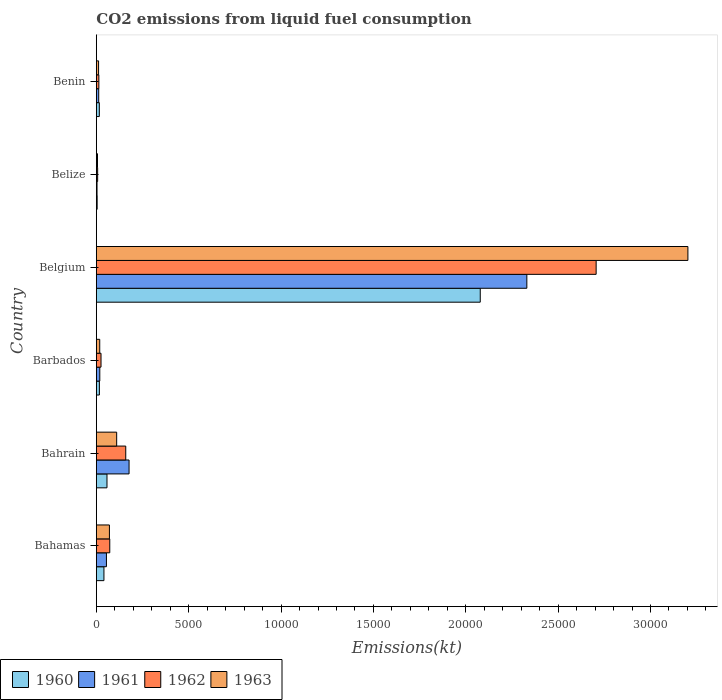How many groups of bars are there?
Offer a very short reply. 6. What is the label of the 5th group of bars from the top?
Offer a terse response. Bahrain. In how many cases, is the number of bars for a given country not equal to the number of legend labels?
Your answer should be compact. 0. What is the amount of CO2 emitted in 1960 in Bahamas?
Offer a very short reply. 410.7. Across all countries, what is the maximum amount of CO2 emitted in 1963?
Your response must be concise. 3.20e+04. Across all countries, what is the minimum amount of CO2 emitted in 1962?
Give a very brief answer. 69.67. In which country was the amount of CO2 emitted in 1962 maximum?
Your answer should be very brief. Belgium. In which country was the amount of CO2 emitted in 1960 minimum?
Your answer should be very brief. Belize. What is the total amount of CO2 emitted in 1963 in the graph?
Provide a succinct answer. 3.42e+04. What is the difference between the amount of CO2 emitted in 1961 in Belgium and that in Benin?
Provide a short and direct response. 2.32e+04. What is the difference between the amount of CO2 emitted in 1963 in Barbados and the amount of CO2 emitted in 1961 in Belgium?
Offer a very short reply. -2.31e+04. What is the average amount of CO2 emitted in 1963 per country?
Your answer should be very brief. 5700.35. What is the difference between the amount of CO2 emitted in 1960 and amount of CO2 emitted in 1962 in Barbados?
Provide a short and direct response. -88.01. In how many countries, is the amount of CO2 emitted in 1962 greater than 4000 kt?
Make the answer very short. 1. What is the ratio of the amount of CO2 emitted in 1963 in Bahamas to that in Benin?
Provide a short and direct response. 5.85. Is the amount of CO2 emitted in 1960 in Barbados less than that in Benin?
Provide a short and direct response. No. Is the difference between the amount of CO2 emitted in 1960 in Bahamas and Benin greater than the difference between the amount of CO2 emitted in 1962 in Bahamas and Benin?
Ensure brevity in your answer.  No. What is the difference between the highest and the second highest amount of CO2 emitted in 1962?
Offer a terse response. 2.55e+04. What is the difference between the highest and the lowest amount of CO2 emitted in 1960?
Your response must be concise. 2.07e+04. What does the 3rd bar from the top in Belgium represents?
Give a very brief answer. 1961. Are all the bars in the graph horizontal?
Make the answer very short. Yes. What is the difference between two consecutive major ticks on the X-axis?
Your answer should be very brief. 5000. Are the values on the major ticks of X-axis written in scientific E-notation?
Ensure brevity in your answer.  No. How many legend labels are there?
Your response must be concise. 4. What is the title of the graph?
Your answer should be very brief. CO2 emissions from liquid fuel consumption. Does "1988" appear as one of the legend labels in the graph?
Give a very brief answer. No. What is the label or title of the X-axis?
Provide a short and direct response. Emissions(kt). What is the Emissions(kt) of 1960 in Bahamas?
Your response must be concise. 410.7. What is the Emissions(kt) in 1961 in Bahamas?
Your answer should be compact. 546.38. What is the Emissions(kt) of 1962 in Bahamas?
Keep it short and to the point. 726.07. What is the Emissions(kt) of 1963 in Bahamas?
Provide a succinct answer. 707.73. What is the Emissions(kt) of 1960 in Bahrain?
Keep it short and to the point. 575.72. What is the Emissions(kt) of 1961 in Bahrain?
Offer a very short reply. 1771.16. What is the Emissions(kt) in 1962 in Bahrain?
Offer a very short reply. 1591.48. What is the Emissions(kt) in 1963 in Bahrain?
Provide a succinct answer. 1100.1. What is the Emissions(kt) in 1960 in Barbados?
Ensure brevity in your answer.  165.01. What is the Emissions(kt) of 1961 in Barbados?
Your response must be concise. 187.02. What is the Emissions(kt) of 1962 in Barbados?
Give a very brief answer. 253.02. What is the Emissions(kt) of 1963 in Barbados?
Offer a terse response. 183.35. What is the Emissions(kt) of 1960 in Belgium?
Ensure brevity in your answer.  2.08e+04. What is the Emissions(kt) in 1961 in Belgium?
Your response must be concise. 2.33e+04. What is the Emissions(kt) of 1962 in Belgium?
Your response must be concise. 2.71e+04. What is the Emissions(kt) of 1963 in Belgium?
Offer a terse response. 3.20e+04. What is the Emissions(kt) in 1960 in Belize?
Provide a short and direct response. 44. What is the Emissions(kt) of 1961 in Belize?
Your answer should be very brief. 36.67. What is the Emissions(kt) of 1962 in Belize?
Your answer should be very brief. 69.67. What is the Emissions(kt) in 1963 in Belize?
Offer a very short reply. 62.34. What is the Emissions(kt) of 1960 in Benin?
Your response must be concise. 161.35. What is the Emissions(kt) of 1961 in Benin?
Your answer should be very brief. 128.34. What is the Emissions(kt) in 1962 in Benin?
Your answer should be very brief. 135.68. What is the Emissions(kt) in 1963 in Benin?
Offer a very short reply. 121.01. Across all countries, what is the maximum Emissions(kt) of 1960?
Ensure brevity in your answer.  2.08e+04. Across all countries, what is the maximum Emissions(kt) of 1961?
Your answer should be compact. 2.33e+04. Across all countries, what is the maximum Emissions(kt) of 1962?
Your response must be concise. 2.71e+04. Across all countries, what is the maximum Emissions(kt) in 1963?
Provide a succinct answer. 3.20e+04. Across all countries, what is the minimum Emissions(kt) in 1960?
Your answer should be very brief. 44. Across all countries, what is the minimum Emissions(kt) in 1961?
Your answer should be very brief. 36.67. Across all countries, what is the minimum Emissions(kt) in 1962?
Your answer should be very brief. 69.67. Across all countries, what is the minimum Emissions(kt) of 1963?
Your answer should be very brief. 62.34. What is the total Emissions(kt) of 1960 in the graph?
Your answer should be very brief. 2.21e+04. What is the total Emissions(kt) in 1961 in the graph?
Ensure brevity in your answer.  2.60e+04. What is the total Emissions(kt) in 1962 in the graph?
Ensure brevity in your answer.  2.98e+04. What is the total Emissions(kt) of 1963 in the graph?
Offer a very short reply. 3.42e+04. What is the difference between the Emissions(kt) in 1960 in Bahamas and that in Bahrain?
Keep it short and to the point. -165.01. What is the difference between the Emissions(kt) of 1961 in Bahamas and that in Bahrain?
Offer a terse response. -1224.78. What is the difference between the Emissions(kt) in 1962 in Bahamas and that in Bahrain?
Provide a short and direct response. -865.41. What is the difference between the Emissions(kt) of 1963 in Bahamas and that in Bahrain?
Keep it short and to the point. -392.37. What is the difference between the Emissions(kt) in 1960 in Bahamas and that in Barbados?
Provide a short and direct response. 245.69. What is the difference between the Emissions(kt) in 1961 in Bahamas and that in Barbados?
Your answer should be compact. 359.37. What is the difference between the Emissions(kt) of 1962 in Bahamas and that in Barbados?
Ensure brevity in your answer.  473.04. What is the difference between the Emissions(kt) of 1963 in Bahamas and that in Barbados?
Your answer should be very brief. 524.38. What is the difference between the Emissions(kt) of 1960 in Bahamas and that in Belgium?
Provide a short and direct response. -2.04e+04. What is the difference between the Emissions(kt) in 1961 in Bahamas and that in Belgium?
Provide a short and direct response. -2.28e+04. What is the difference between the Emissions(kt) in 1962 in Bahamas and that in Belgium?
Your answer should be very brief. -2.63e+04. What is the difference between the Emissions(kt) of 1963 in Bahamas and that in Belgium?
Make the answer very short. -3.13e+04. What is the difference between the Emissions(kt) of 1960 in Bahamas and that in Belize?
Your response must be concise. 366.7. What is the difference between the Emissions(kt) in 1961 in Bahamas and that in Belize?
Make the answer very short. 509.71. What is the difference between the Emissions(kt) in 1962 in Bahamas and that in Belize?
Ensure brevity in your answer.  656.39. What is the difference between the Emissions(kt) of 1963 in Bahamas and that in Belize?
Offer a very short reply. 645.39. What is the difference between the Emissions(kt) in 1960 in Bahamas and that in Benin?
Your answer should be very brief. 249.36. What is the difference between the Emissions(kt) in 1961 in Bahamas and that in Benin?
Offer a very short reply. 418.04. What is the difference between the Emissions(kt) of 1962 in Bahamas and that in Benin?
Provide a short and direct response. 590.39. What is the difference between the Emissions(kt) of 1963 in Bahamas and that in Benin?
Provide a succinct answer. 586.72. What is the difference between the Emissions(kt) of 1960 in Bahrain and that in Barbados?
Make the answer very short. 410.7. What is the difference between the Emissions(kt) of 1961 in Bahrain and that in Barbados?
Keep it short and to the point. 1584.14. What is the difference between the Emissions(kt) in 1962 in Bahrain and that in Barbados?
Your answer should be very brief. 1338.45. What is the difference between the Emissions(kt) in 1963 in Bahrain and that in Barbados?
Your answer should be compact. 916.75. What is the difference between the Emissions(kt) in 1960 in Bahrain and that in Belgium?
Offer a very short reply. -2.02e+04. What is the difference between the Emissions(kt) in 1961 in Bahrain and that in Belgium?
Your response must be concise. -2.15e+04. What is the difference between the Emissions(kt) in 1962 in Bahrain and that in Belgium?
Provide a succinct answer. -2.55e+04. What is the difference between the Emissions(kt) in 1963 in Bahrain and that in Belgium?
Your answer should be very brief. -3.09e+04. What is the difference between the Emissions(kt) in 1960 in Bahrain and that in Belize?
Your response must be concise. 531.72. What is the difference between the Emissions(kt) of 1961 in Bahrain and that in Belize?
Give a very brief answer. 1734.49. What is the difference between the Emissions(kt) in 1962 in Bahrain and that in Belize?
Make the answer very short. 1521.81. What is the difference between the Emissions(kt) of 1963 in Bahrain and that in Belize?
Make the answer very short. 1037.76. What is the difference between the Emissions(kt) of 1960 in Bahrain and that in Benin?
Your answer should be compact. 414.37. What is the difference between the Emissions(kt) of 1961 in Bahrain and that in Benin?
Ensure brevity in your answer.  1642.82. What is the difference between the Emissions(kt) of 1962 in Bahrain and that in Benin?
Provide a short and direct response. 1455.8. What is the difference between the Emissions(kt) in 1963 in Bahrain and that in Benin?
Provide a succinct answer. 979.09. What is the difference between the Emissions(kt) of 1960 in Barbados and that in Belgium?
Your answer should be compact. -2.06e+04. What is the difference between the Emissions(kt) of 1961 in Barbados and that in Belgium?
Offer a very short reply. -2.31e+04. What is the difference between the Emissions(kt) of 1962 in Barbados and that in Belgium?
Provide a short and direct response. -2.68e+04. What is the difference between the Emissions(kt) of 1963 in Barbados and that in Belgium?
Give a very brief answer. -3.18e+04. What is the difference between the Emissions(kt) of 1960 in Barbados and that in Belize?
Offer a very short reply. 121.01. What is the difference between the Emissions(kt) of 1961 in Barbados and that in Belize?
Provide a short and direct response. 150.35. What is the difference between the Emissions(kt) in 1962 in Barbados and that in Belize?
Provide a succinct answer. 183.35. What is the difference between the Emissions(kt) in 1963 in Barbados and that in Belize?
Your answer should be very brief. 121.01. What is the difference between the Emissions(kt) in 1960 in Barbados and that in Benin?
Offer a very short reply. 3.67. What is the difference between the Emissions(kt) in 1961 in Barbados and that in Benin?
Provide a short and direct response. 58.67. What is the difference between the Emissions(kt) of 1962 in Barbados and that in Benin?
Offer a terse response. 117.34. What is the difference between the Emissions(kt) in 1963 in Barbados and that in Benin?
Offer a very short reply. 62.34. What is the difference between the Emissions(kt) of 1960 in Belgium and that in Belize?
Provide a succinct answer. 2.07e+04. What is the difference between the Emissions(kt) in 1961 in Belgium and that in Belize?
Keep it short and to the point. 2.33e+04. What is the difference between the Emissions(kt) in 1962 in Belgium and that in Belize?
Provide a succinct answer. 2.70e+04. What is the difference between the Emissions(kt) of 1963 in Belgium and that in Belize?
Offer a very short reply. 3.20e+04. What is the difference between the Emissions(kt) in 1960 in Belgium and that in Benin?
Your answer should be compact. 2.06e+04. What is the difference between the Emissions(kt) of 1961 in Belgium and that in Benin?
Make the answer very short. 2.32e+04. What is the difference between the Emissions(kt) in 1962 in Belgium and that in Benin?
Your answer should be very brief. 2.69e+04. What is the difference between the Emissions(kt) in 1963 in Belgium and that in Benin?
Provide a short and direct response. 3.19e+04. What is the difference between the Emissions(kt) of 1960 in Belize and that in Benin?
Provide a succinct answer. -117.34. What is the difference between the Emissions(kt) in 1961 in Belize and that in Benin?
Provide a succinct answer. -91.67. What is the difference between the Emissions(kt) of 1962 in Belize and that in Benin?
Provide a short and direct response. -66.01. What is the difference between the Emissions(kt) of 1963 in Belize and that in Benin?
Keep it short and to the point. -58.67. What is the difference between the Emissions(kt) in 1960 in Bahamas and the Emissions(kt) in 1961 in Bahrain?
Offer a terse response. -1360.46. What is the difference between the Emissions(kt) in 1960 in Bahamas and the Emissions(kt) in 1962 in Bahrain?
Your answer should be very brief. -1180.77. What is the difference between the Emissions(kt) in 1960 in Bahamas and the Emissions(kt) in 1963 in Bahrain?
Provide a short and direct response. -689.4. What is the difference between the Emissions(kt) of 1961 in Bahamas and the Emissions(kt) of 1962 in Bahrain?
Keep it short and to the point. -1045.1. What is the difference between the Emissions(kt) of 1961 in Bahamas and the Emissions(kt) of 1963 in Bahrain?
Ensure brevity in your answer.  -553.72. What is the difference between the Emissions(kt) of 1962 in Bahamas and the Emissions(kt) of 1963 in Bahrain?
Offer a terse response. -374.03. What is the difference between the Emissions(kt) of 1960 in Bahamas and the Emissions(kt) of 1961 in Barbados?
Your response must be concise. 223.69. What is the difference between the Emissions(kt) of 1960 in Bahamas and the Emissions(kt) of 1962 in Barbados?
Offer a terse response. 157.68. What is the difference between the Emissions(kt) of 1960 in Bahamas and the Emissions(kt) of 1963 in Barbados?
Your answer should be compact. 227.35. What is the difference between the Emissions(kt) in 1961 in Bahamas and the Emissions(kt) in 1962 in Barbados?
Make the answer very short. 293.36. What is the difference between the Emissions(kt) in 1961 in Bahamas and the Emissions(kt) in 1963 in Barbados?
Provide a succinct answer. 363.03. What is the difference between the Emissions(kt) of 1962 in Bahamas and the Emissions(kt) of 1963 in Barbados?
Your response must be concise. 542.72. What is the difference between the Emissions(kt) of 1960 in Bahamas and the Emissions(kt) of 1961 in Belgium?
Provide a succinct answer. -2.29e+04. What is the difference between the Emissions(kt) in 1960 in Bahamas and the Emissions(kt) in 1962 in Belgium?
Your answer should be compact. -2.66e+04. What is the difference between the Emissions(kt) of 1960 in Bahamas and the Emissions(kt) of 1963 in Belgium?
Your response must be concise. -3.16e+04. What is the difference between the Emissions(kt) of 1961 in Bahamas and the Emissions(kt) of 1962 in Belgium?
Your answer should be very brief. -2.65e+04. What is the difference between the Emissions(kt) of 1961 in Bahamas and the Emissions(kt) of 1963 in Belgium?
Ensure brevity in your answer.  -3.15e+04. What is the difference between the Emissions(kt) in 1962 in Bahamas and the Emissions(kt) in 1963 in Belgium?
Provide a short and direct response. -3.13e+04. What is the difference between the Emissions(kt) of 1960 in Bahamas and the Emissions(kt) of 1961 in Belize?
Offer a terse response. 374.03. What is the difference between the Emissions(kt) in 1960 in Bahamas and the Emissions(kt) in 1962 in Belize?
Keep it short and to the point. 341.03. What is the difference between the Emissions(kt) in 1960 in Bahamas and the Emissions(kt) in 1963 in Belize?
Your answer should be compact. 348.37. What is the difference between the Emissions(kt) in 1961 in Bahamas and the Emissions(kt) in 1962 in Belize?
Give a very brief answer. 476.71. What is the difference between the Emissions(kt) of 1961 in Bahamas and the Emissions(kt) of 1963 in Belize?
Your response must be concise. 484.04. What is the difference between the Emissions(kt) in 1962 in Bahamas and the Emissions(kt) in 1963 in Belize?
Provide a succinct answer. 663.73. What is the difference between the Emissions(kt) in 1960 in Bahamas and the Emissions(kt) in 1961 in Benin?
Provide a succinct answer. 282.36. What is the difference between the Emissions(kt) of 1960 in Bahamas and the Emissions(kt) of 1962 in Benin?
Your answer should be compact. 275.02. What is the difference between the Emissions(kt) of 1960 in Bahamas and the Emissions(kt) of 1963 in Benin?
Offer a terse response. 289.69. What is the difference between the Emissions(kt) in 1961 in Bahamas and the Emissions(kt) in 1962 in Benin?
Provide a short and direct response. 410.7. What is the difference between the Emissions(kt) in 1961 in Bahamas and the Emissions(kt) in 1963 in Benin?
Your answer should be compact. 425.37. What is the difference between the Emissions(kt) of 1962 in Bahamas and the Emissions(kt) of 1963 in Benin?
Offer a terse response. 605.05. What is the difference between the Emissions(kt) in 1960 in Bahrain and the Emissions(kt) in 1961 in Barbados?
Your response must be concise. 388.7. What is the difference between the Emissions(kt) of 1960 in Bahrain and the Emissions(kt) of 1962 in Barbados?
Offer a very short reply. 322.7. What is the difference between the Emissions(kt) of 1960 in Bahrain and the Emissions(kt) of 1963 in Barbados?
Your answer should be compact. 392.37. What is the difference between the Emissions(kt) in 1961 in Bahrain and the Emissions(kt) in 1962 in Barbados?
Provide a short and direct response. 1518.14. What is the difference between the Emissions(kt) in 1961 in Bahrain and the Emissions(kt) in 1963 in Barbados?
Offer a terse response. 1587.81. What is the difference between the Emissions(kt) of 1962 in Bahrain and the Emissions(kt) of 1963 in Barbados?
Keep it short and to the point. 1408.13. What is the difference between the Emissions(kt) of 1960 in Bahrain and the Emissions(kt) of 1961 in Belgium?
Your answer should be very brief. -2.27e+04. What is the difference between the Emissions(kt) in 1960 in Bahrain and the Emissions(kt) in 1962 in Belgium?
Give a very brief answer. -2.65e+04. What is the difference between the Emissions(kt) of 1960 in Bahrain and the Emissions(kt) of 1963 in Belgium?
Provide a short and direct response. -3.15e+04. What is the difference between the Emissions(kt) in 1961 in Bahrain and the Emissions(kt) in 1962 in Belgium?
Ensure brevity in your answer.  -2.53e+04. What is the difference between the Emissions(kt) in 1961 in Bahrain and the Emissions(kt) in 1963 in Belgium?
Provide a succinct answer. -3.03e+04. What is the difference between the Emissions(kt) in 1962 in Bahrain and the Emissions(kt) in 1963 in Belgium?
Keep it short and to the point. -3.04e+04. What is the difference between the Emissions(kt) of 1960 in Bahrain and the Emissions(kt) of 1961 in Belize?
Make the answer very short. 539.05. What is the difference between the Emissions(kt) of 1960 in Bahrain and the Emissions(kt) of 1962 in Belize?
Give a very brief answer. 506.05. What is the difference between the Emissions(kt) in 1960 in Bahrain and the Emissions(kt) in 1963 in Belize?
Give a very brief answer. 513.38. What is the difference between the Emissions(kt) of 1961 in Bahrain and the Emissions(kt) of 1962 in Belize?
Provide a short and direct response. 1701.49. What is the difference between the Emissions(kt) in 1961 in Bahrain and the Emissions(kt) in 1963 in Belize?
Provide a short and direct response. 1708.82. What is the difference between the Emissions(kt) of 1962 in Bahrain and the Emissions(kt) of 1963 in Belize?
Make the answer very short. 1529.14. What is the difference between the Emissions(kt) of 1960 in Bahrain and the Emissions(kt) of 1961 in Benin?
Offer a terse response. 447.37. What is the difference between the Emissions(kt) of 1960 in Bahrain and the Emissions(kt) of 1962 in Benin?
Ensure brevity in your answer.  440.04. What is the difference between the Emissions(kt) of 1960 in Bahrain and the Emissions(kt) of 1963 in Benin?
Your response must be concise. 454.71. What is the difference between the Emissions(kt) in 1961 in Bahrain and the Emissions(kt) in 1962 in Benin?
Give a very brief answer. 1635.48. What is the difference between the Emissions(kt) of 1961 in Bahrain and the Emissions(kt) of 1963 in Benin?
Your answer should be very brief. 1650.15. What is the difference between the Emissions(kt) in 1962 in Bahrain and the Emissions(kt) in 1963 in Benin?
Provide a succinct answer. 1470.47. What is the difference between the Emissions(kt) of 1960 in Barbados and the Emissions(kt) of 1961 in Belgium?
Your answer should be very brief. -2.31e+04. What is the difference between the Emissions(kt) of 1960 in Barbados and the Emissions(kt) of 1962 in Belgium?
Make the answer very short. -2.69e+04. What is the difference between the Emissions(kt) in 1960 in Barbados and the Emissions(kt) in 1963 in Belgium?
Your answer should be compact. -3.19e+04. What is the difference between the Emissions(kt) of 1961 in Barbados and the Emissions(kt) of 1962 in Belgium?
Your answer should be very brief. -2.69e+04. What is the difference between the Emissions(kt) of 1961 in Barbados and the Emissions(kt) of 1963 in Belgium?
Provide a succinct answer. -3.18e+04. What is the difference between the Emissions(kt) of 1962 in Barbados and the Emissions(kt) of 1963 in Belgium?
Offer a very short reply. -3.18e+04. What is the difference between the Emissions(kt) of 1960 in Barbados and the Emissions(kt) of 1961 in Belize?
Your answer should be very brief. 128.34. What is the difference between the Emissions(kt) in 1960 in Barbados and the Emissions(kt) in 1962 in Belize?
Provide a succinct answer. 95.34. What is the difference between the Emissions(kt) of 1960 in Barbados and the Emissions(kt) of 1963 in Belize?
Give a very brief answer. 102.68. What is the difference between the Emissions(kt) of 1961 in Barbados and the Emissions(kt) of 1962 in Belize?
Offer a very short reply. 117.34. What is the difference between the Emissions(kt) in 1961 in Barbados and the Emissions(kt) in 1963 in Belize?
Give a very brief answer. 124.68. What is the difference between the Emissions(kt) in 1962 in Barbados and the Emissions(kt) in 1963 in Belize?
Make the answer very short. 190.68. What is the difference between the Emissions(kt) of 1960 in Barbados and the Emissions(kt) of 1961 in Benin?
Your response must be concise. 36.67. What is the difference between the Emissions(kt) of 1960 in Barbados and the Emissions(kt) of 1962 in Benin?
Your response must be concise. 29.34. What is the difference between the Emissions(kt) in 1960 in Barbados and the Emissions(kt) in 1963 in Benin?
Ensure brevity in your answer.  44. What is the difference between the Emissions(kt) in 1961 in Barbados and the Emissions(kt) in 1962 in Benin?
Offer a very short reply. 51.34. What is the difference between the Emissions(kt) in 1961 in Barbados and the Emissions(kt) in 1963 in Benin?
Your answer should be compact. 66.01. What is the difference between the Emissions(kt) in 1962 in Barbados and the Emissions(kt) in 1963 in Benin?
Keep it short and to the point. 132.01. What is the difference between the Emissions(kt) of 1960 in Belgium and the Emissions(kt) of 1961 in Belize?
Make the answer very short. 2.07e+04. What is the difference between the Emissions(kt) in 1960 in Belgium and the Emissions(kt) in 1962 in Belize?
Give a very brief answer. 2.07e+04. What is the difference between the Emissions(kt) in 1960 in Belgium and the Emissions(kt) in 1963 in Belize?
Give a very brief answer. 2.07e+04. What is the difference between the Emissions(kt) in 1961 in Belgium and the Emissions(kt) in 1962 in Belize?
Offer a terse response. 2.32e+04. What is the difference between the Emissions(kt) in 1961 in Belgium and the Emissions(kt) in 1963 in Belize?
Give a very brief answer. 2.32e+04. What is the difference between the Emissions(kt) in 1962 in Belgium and the Emissions(kt) in 1963 in Belize?
Provide a succinct answer. 2.70e+04. What is the difference between the Emissions(kt) of 1960 in Belgium and the Emissions(kt) of 1961 in Benin?
Your answer should be very brief. 2.07e+04. What is the difference between the Emissions(kt) in 1960 in Belgium and the Emissions(kt) in 1962 in Benin?
Offer a terse response. 2.06e+04. What is the difference between the Emissions(kt) in 1960 in Belgium and the Emissions(kt) in 1963 in Benin?
Give a very brief answer. 2.07e+04. What is the difference between the Emissions(kt) of 1961 in Belgium and the Emissions(kt) of 1962 in Benin?
Your response must be concise. 2.32e+04. What is the difference between the Emissions(kt) in 1961 in Belgium and the Emissions(kt) in 1963 in Benin?
Give a very brief answer. 2.32e+04. What is the difference between the Emissions(kt) of 1962 in Belgium and the Emissions(kt) of 1963 in Benin?
Provide a succinct answer. 2.69e+04. What is the difference between the Emissions(kt) of 1960 in Belize and the Emissions(kt) of 1961 in Benin?
Give a very brief answer. -84.34. What is the difference between the Emissions(kt) in 1960 in Belize and the Emissions(kt) in 1962 in Benin?
Give a very brief answer. -91.67. What is the difference between the Emissions(kt) in 1960 in Belize and the Emissions(kt) in 1963 in Benin?
Offer a very short reply. -77.01. What is the difference between the Emissions(kt) in 1961 in Belize and the Emissions(kt) in 1962 in Benin?
Offer a terse response. -99.01. What is the difference between the Emissions(kt) of 1961 in Belize and the Emissions(kt) of 1963 in Benin?
Make the answer very short. -84.34. What is the difference between the Emissions(kt) in 1962 in Belize and the Emissions(kt) in 1963 in Benin?
Ensure brevity in your answer.  -51.34. What is the average Emissions(kt) in 1960 per country?
Provide a succinct answer. 3690.22. What is the average Emissions(kt) in 1961 per country?
Provide a succinct answer. 4329.5. What is the average Emissions(kt) of 1962 per country?
Your answer should be very brief. 4972.45. What is the average Emissions(kt) of 1963 per country?
Your answer should be compact. 5700.35. What is the difference between the Emissions(kt) in 1960 and Emissions(kt) in 1961 in Bahamas?
Offer a terse response. -135.68. What is the difference between the Emissions(kt) of 1960 and Emissions(kt) of 1962 in Bahamas?
Your answer should be very brief. -315.36. What is the difference between the Emissions(kt) of 1960 and Emissions(kt) of 1963 in Bahamas?
Your answer should be compact. -297.03. What is the difference between the Emissions(kt) of 1961 and Emissions(kt) of 1962 in Bahamas?
Your answer should be compact. -179.68. What is the difference between the Emissions(kt) of 1961 and Emissions(kt) of 1963 in Bahamas?
Ensure brevity in your answer.  -161.35. What is the difference between the Emissions(kt) in 1962 and Emissions(kt) in 1963 in Bahamas?
Keep it short and to the point. 18.34. What is the difference between the Emissions(kt) in 1960 and Emissions(kt) in 1961 in Bahrain?
Your response must be concise. -1195.44. What is the difference between the Emissions(kt) in 1960 and Emissions(kt) in 1962 in Bahrain?
Your answer should be very brief. -1015.76. What is the difference between the Emissions(kt) in 1960 and Emissions(kt) in 1963 in Bahrain?
Give a very brief answer. -524.38. What is the difference between the Emissions(kt) in 1961 and Emissions(kt) in 1962 in Bahrain?
Your response must be concise. 179.68. What is the difference between the Emissions(kt) in 1961 and Emissions(kt) in 1963 in Bahrain?
Offer a terse response. 671.06. What is the difference between the Emissions(kt) of 1962 and Emissions(kt) of 1963 in Bahrain?
Provide a succinct answer. 491.38. What is the difference between the Emissions(kt) of 1960 and Emissions(kt) of 1961 in Barbados?
Give a very brief answer. -22. What is the difference between the Emissions(kt) in 1960 and Emissions(kt) in 1962 in Barbados?
Offer a very short reply. -88.01. What is the difference between the Emissions(kt) of 1960 and Emissions(kt) of 1963 in Barbados?
Your answer should be very brief. -18.34. What is the difference between the Emissions(kt) in 1961 and Emissions(kt) in 1962 in Barbados?
Offer a very short reply. -66.01. What is the difference between the Emissions(kt) of 1961 and Emissions(kt) of 1963 in Barbados?
Provide a short and direct response. 3.67. What is the difference between the Emissions(kt) of 1962 and Emissions(kt) of 1963 in Barbados?
Ensure brevity in your answer.  69.67. What is the difference between the Emissions(kt) in 1960 and Emissions(kt) in 1961 in Belgium?
Your answer should be compact. -2522.9. What is the difference between the Emissions(kt) of 1960 and Emissions(kt) of 1962 in Belgium?
Your response must be concise. -6274.24. What is the difference between the Emissions(kt) in 1960 and Emissions(kt) in 1963 in Belgium?
Give a very brief answer. -1.12e+04. What is the difference between the Emissions(kt) in 1961 and Emissions(kt) in 1962 in Belgium?
Your response must be concise. -3751.34. What is the difference between the Emissions(kt) in 1961 and Emissions(kt) in 1963 in Belgium?
Ensure brevity in your answer.  -8720.13. What is the difference between the Emissions(kt) in 1962 and Emissions(kt) in 1963 in Belgium?
Your answer should be very brief. -4968.78. What is the difference between the Emissions(kt) of 1960 and Emissions(kt) of 1961 in Belize?
Your answer should be very brief. 7.33. What is the difference between the Emissions(kt) of 1960 and Emissions(kt) of 1962 in Belize?
Keep it short and to the point. -25.67. What is the difference between the Emissions(kt) in 1960 and Emissions(kt) in 1963 in Belize?
Provide a succinct answer. -18.34. What is the difference between the Emissions(kt) in 1961 and Emissions(kt) in 1962 in Belize?
Provide a short and direct response. -33. What is the difference between the Emissions(kt) in 1961 and Emissions(kt) in 1963 in Belize?
Provide a succinct answer. -25.67. What is the difference between the Emissions(kt) of 1962 and Emissions(kt) of 1963 in Belize?
Offer a terse response. 7.33. What is the difference between the Emissions(kt) in 1960 and Emissions(kt) in 1961 in Benin?
Provide a short and direct response. 33. What is the difference between the Emissions(kt) in 1960 and Emissions(kt) in 1962 in Benin?
Keep it short and to the point. 25.67. What is the difference between the Emissions(kt) in 1960 and Emissions(kt) in 1963 in Benin?
Keep it short and to the point. 40.34. What is the difference between the Emissions(kt) of 1961 and Emissions(kt) of 1962 in Benin?
Make the answer very short. -7.33. What is the difference between the Emissions(kt) of 1961 and Emissions(kt) of 1963 in Benin?
Make the answer very short. 7.33. What is the difference between the Emissions(kt) in 1962 and Emissions(kt) in 1963 in Benin?
Your response must be concise. 14.67. What is the ratio of the Emissions(kt) of 1960 in Bahamas to that in Bahrain?
Offer a terse response. 0.71. What is the ratio of the Emissions(kt) of 1961 in Bahamas to that in Bahrain?
Your response must be concise. 0.31. What is the ratio of the Emissions(kt) of 1962 in Bahamas to that in Bahrain?
Offer a very short reply. 0.46. What is the ratio of the Emissions(kt) of 1963 in Bahamas to that in Bahrain?
Give a very brief answer. 0.64. What is the ratio of the Emissions(kt) in 1960 in Bahamas to that in Barbados?
Your answer should be compact. 2.49. What is the ratio of the Emissions(kt) of 1961 in Bahamas to that in Barbados?
Keep it short and to the point. 2.92. What is the ratio of the Emissions(kt) in 1962 in Bahamas to that in Barbados?
Offer a very short reply. 2.87. What is the ratio of the Emissions(kt) in 1963 in Bahamas to that in Barbados?
Provide a succinct answer. 3.86. What is the ratio of the Emissions(kt) of 1960 in Bahamas to that in Belgium?
Offer a very short reply. 0.02. What is the ratio of the Emissions(kt) in 1961 in Bahamas to that in Belgium?
Make the answer very short. 0.02. What is the ratio of the Emissions(kt) in 1962 in Bahamas to that in Belgium?
Your answer should be very brief. 0.03. What is the ratio of the Emissions(kt) in 1963 in Bahamas to that in Belgium?
Ensure brevity in your answer.  0.02. What is the ratio of the Emissions(kt) in 1960 in Bahamas to that in Belize?
Make the answer very short. 9.33. What is the ratio of the Emissions(kt) of 1962 in Bahamas to that in Belize?
Offer a terse response. 10.42. What is the ratio of the Emissions(kt) of 1963 in Bahamas to that in Belize?
Offer a very short reply. 11.35. What is the ratio of the Emissions(kt) in 1960 in Bahamas to that in Benin?
Keep it short and to the point. 2.55. What is the ratio of the Emissions(kt) of 1961 in Bahamas to that in Benin?
Keep it short and to the point. 4.26. What is the ratio of the Emissions(kt) in 1962 in Bahamas to that in Benin?
Provide a succinct answer. 5.35. What is the ratio of the Emissions(kt) of 1963 in Bahamas to that in Benin?
Your answer should be very brief. 5.85. What is the ratio of the Emissions(kt) in 1960 in Bahrain to that in Barbados?
Offer a very short reply. 3.49. What is the ratio of the Emissions(kt) of 1961 in Bahrain to that in Barbados?
Your answer should be very brief. 9.47. What is the ratio of the Emissions(kt) of 1962 in Bahrain to that in Barbados?
Provide a short and direct response. 6.29. What is the ratio of the Emissions(kt) in 1963 in Bahrain to that in Barbados?
Your response must be concise. 6. What is the ratio of the Emissions(kt) of 1960 in Bahrain to that in Belgium?
Keep it short and to the point. 0.03. What is the ratio of the Emissions(kt) in 1961 in Bahrain to that in Belgium?
Offer a very short reply. 0.08. What is the ratio of the Emissions(kt) of 1962 in Bahrain to that in Belgium?
Provide a succinct answer. 0.06. What is the ratio of the Emissions(kt) in 1963 in Bahrain to that in Belgium?
Offer a very short reply. 0.03. What is the ratio of the Emissions(kt) in 1960 in Bahrain to that in Belize?
Your response must be concise. 13.08. What is the ratio of the Emissions(kt) of 1961 in Bahrain to that in Belize?
Make the answer very short. 48.3. What is the ratio of the Emissions(kt) in 1962 in Bahrain to that in Belize?
Offer a very short reply. 22.84. What is the ratio of the Emissions(kt) in 1963 in Bahrain to that in Belize?
Keep it short and to the point. 17.65. What is the ratio of the Emissions(kt) in 1960 in Bahrain to that in Benin?
Keep it short and to the point. 3.57. What is the ratio of the Emissions(kt) of 1961 in Bahrain to that in Benin?
Your answer should be compact. 13.8. What is the ratio of the Emissions(kt) in 1962 in Bahrain to that in Benin?
Make the answer very short. 11.73. What is the ratio of the Emissions(kt) in 1963 in Bahrain to that in Benin?
Offer a terse response. 9.09. What is the ratio of the Emissions(kt) of 1960 in Barbados to that in Belgium?
Your answer should be very brief. 0.01. What is the ratio of the Emissions(kt) of 1961 in Barbados to that in Belgium?
Keep it short and to the point. 0.01. What is the ratio of the Emissions(kt) of 1962 in Barbados to that in Belgium?
Offer a very short reply. 0.01. What is the ratio of the Emissions(kt) of 1963 in Barbados to that in Belgium?
Your answer should be very brief. 0.01. What is the ratio of the Emissions(kt) in 1960 in Barbados to that in Belize?
Offer a terse response. 3.75. What is the ratio of the Emissions(kt) in 1962 in Barbados to that in Belize?
Your answer should be very brief. 3.63. What is the ratio of the Emissions(kt) of 1963 in Barbados to that in Belize?
Ensure brevity in your answer.  2.94. What is the ratio of the Emissions(kt) of 1960 in Barbados to that in Benin?
Offer a terse response. 1.02. What is the ratio of the Emissions(kt) in 1961 in Barbados to that in Benin?
Make the answer very short. 1.46. What is the ratio of the Emissions(kt) in 1962 in Barbados to that in Benin?
Offer a very short reply. 1.86. What is the ratio of the Emissions(kt) of 1963 in Barbados to that in Benin?
Keep it short and to the point. 1.52. What is the ratio of the Emissions(kt) in 1960 in Belgium to that in Belize?
Provide a short and direct response. 472.33. What is the ratio of the Emissions(kt) of 1961 in Belgium to that in Belize?
Your answer should be compact. 635.6. What is the ratio of the Emissions(kt) of 1962 in Belgium to that in Belize?
Make the answer very short. 388.37. What is the ratio of the Emissions(kt) of 1963 in Belgium to that in Belize?
Your answer should be very brief. 513.76. What is the ratio of the Emissions(kt) in 1960 in Belgium to that in Benin?
Your answer should be very brief. 128.82. What is the ratio of the Emissions(kt) of 1961 in Belgium to that in Benin?
Offer a very short reply. 181.6. What is the ratio of the Emissions(kt) in 1962 in Belgium to that in Benin?
Make the answer very short. 199.43. What is the ratio of the Emissions(kt) of 1963 in Belgium to that in Benin?
Provide a succinct answer. 264.67. What is the ratio of the Emissions(kt) of 1960 in Belize to that in Benin?
Give a very brief answer. 0.27. What is the ratio of the Emissions(kt) of 1961 in Belize to that in Benin?
Provide a succinct answer. 0.29. What is the ratio of the Emissions(kt) of 1962 in Belize to that in Benin?
Keep it short and to the point. 0.51. What is the ratio of the Emissions(kt) of 1963 in Belize to that in Benin?
Give a very brief answer. 0.52. What is the difference between the highest and the second highest Emissions(kt) in 1960?
Give a very brief answer. 2.02e+04. What is the difference between the highest and the second highest Emissions(kt) in 1961?
Your answer should be compact. 2.15e+04. What is the difference between the highest and the second highest Emissions(kt) in 1962?
Offer a very short reply. 2.55e+04. What is the difference between the highest and the second highest Emissions(kt) of 1963?
Keep it short and to the point. 3.09e+04. What is the difference between the highest and the lowest Emissions(kt) in 1960?
Offer a very short reply. 2.07e+04. What is the difference between the highest and the lowest Emissions(kt) of 1961?
Keep it short and to the point. 2.33e+04. What is the difference between the highest and the lowest Emissions(kt) of 1962?
Ensure brevity in your answer.  2.70e+04. What is the difference between the highest and the lowest Emissions(kt) of 1963?
Ensure brevity in your answer.  3.20e+04. 